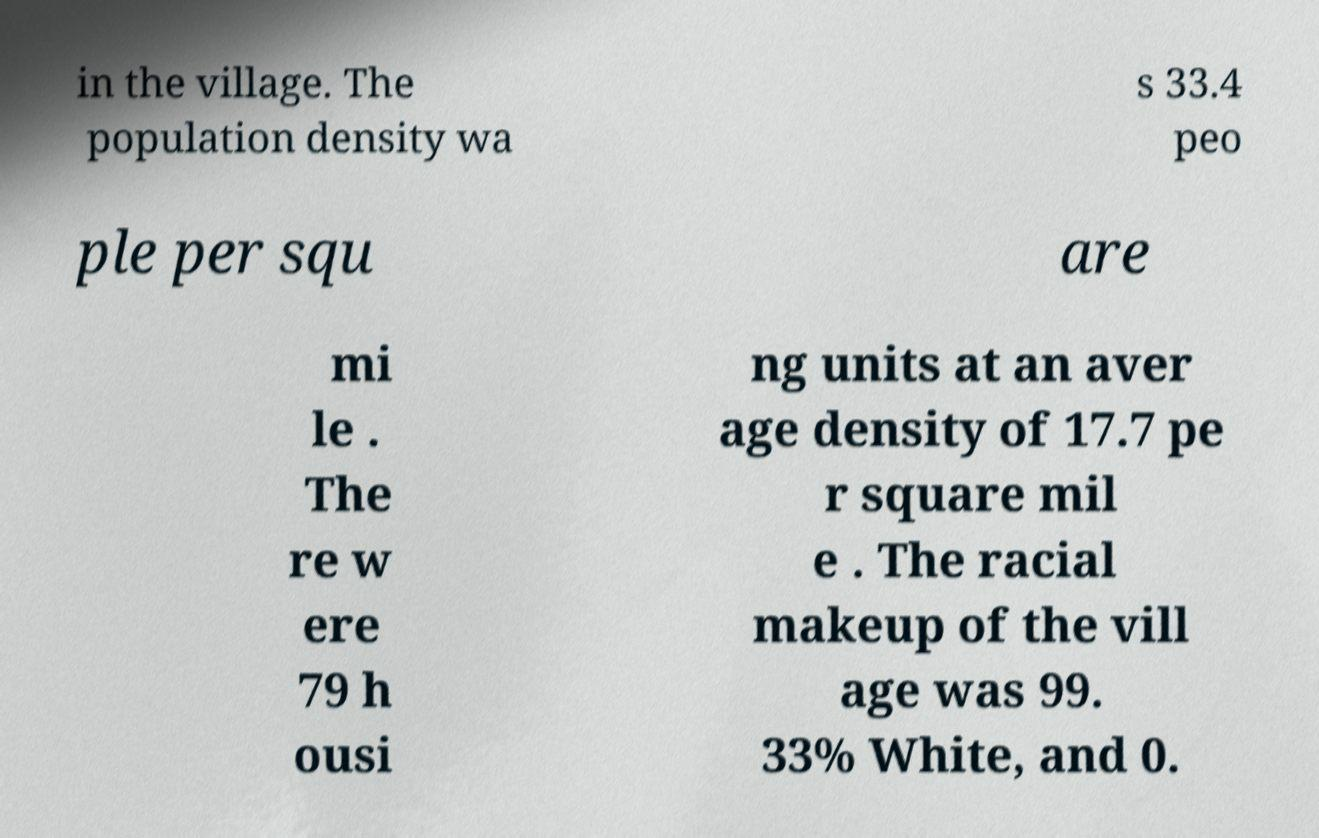Please read and relay the text visible in this image. What does it say? in the village. The population density wa s 33.4 peo ple per squ are mi le . The re w ere 79 h ousi ng units at an aver age density of 17.7 pe r square mil e . The racial makeup of the vill age was 99. 33% White, and 0. 